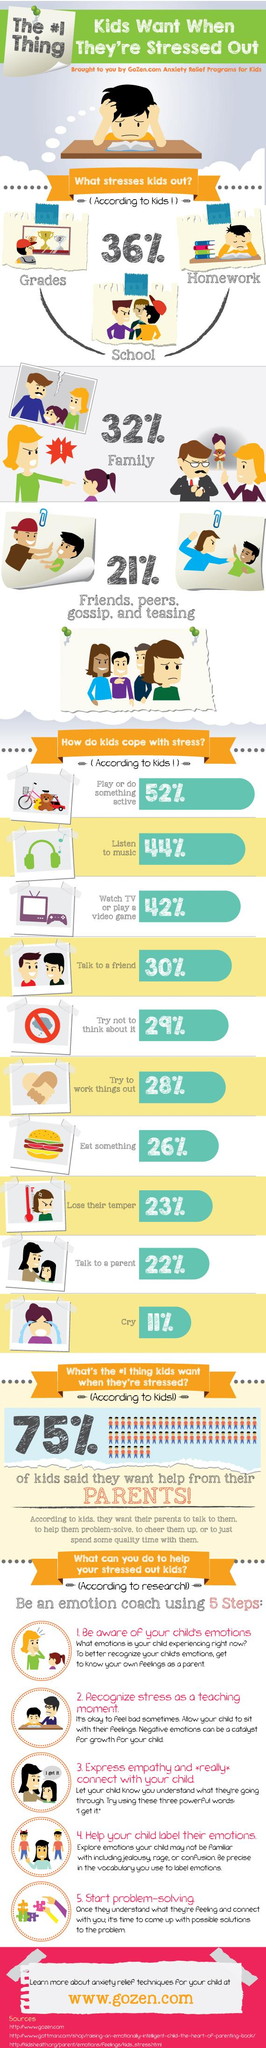Give some essential details in this illustration. According to a recent study, 78% of children cope with stress without seeking help from a parent. According to a recent survey, a significant percentage of children, approximately 56%, cope with stress without listening to music. According to a recent study, 89% of children are able to cope with stress without crying. According to a recent study, 70% of children are able to cope with stress without talking to a friend. In a recent survey, it was found that 58% of children are able to cope with stress without resorting to watching television. 